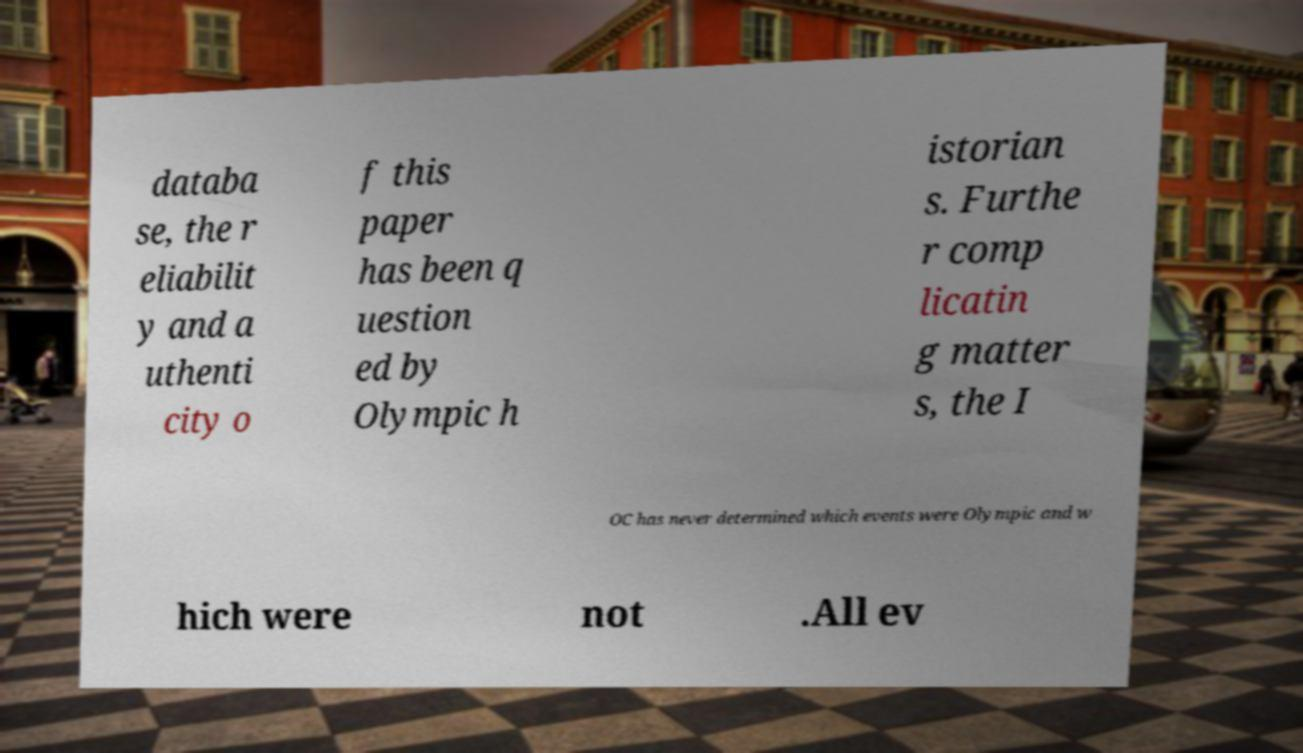For documentation purposes, I need the text within this image transcribed. Could you provide that? databa se, the r eliabilit y and a uthenti city o f this paper has been q uestion ed by Olympic h istorian s. Furthe r comp licatin g matter s, the I OC has never determined which events were Olympic and w hich were not .All ev 